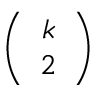Convert formula to latex. <formula><loc_0><loc_0><loc_500><loc_500>\left ( \begin{array} { c } { k } \\ { 2 } \end{array} \right )</formula> 